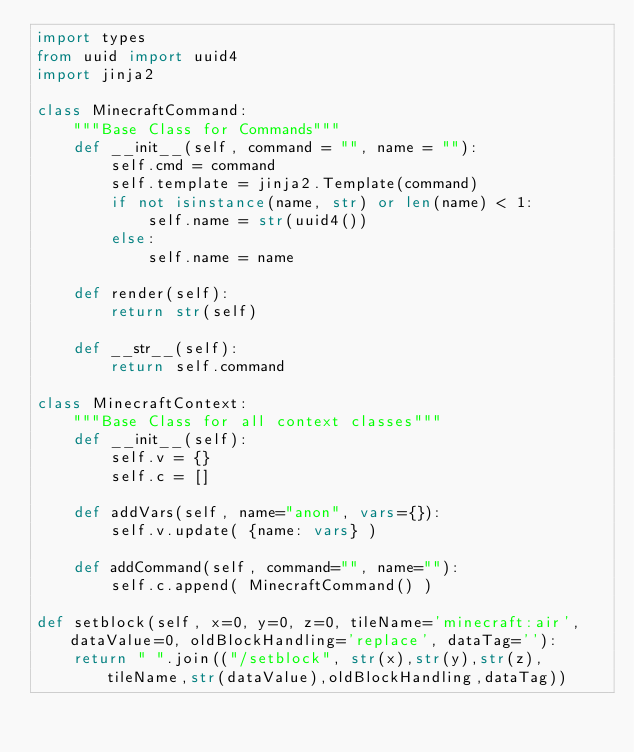<code> <loc_0><loc_0><loc_500><loc_500><_Python_>import types
from uuid import uuid4
import jinja2

class MinecraftCommand:
	"""Base Class for Commands"""
	def __init__(self, command = "", name = ""):
		self.cmd = command
		self.template = jinja2.Template(command)
		if not isinstance(name, str) or len(name) < 1:
			self.name = str(uuid4())
		else:
			self.name = name
	
	def render(self):
		return str(self)
	
	def __str__(self):
		return self.command

class MinecraftContext:
	"""Base Class for all context classes"""
	def __init__(self):
		self.v = {}
		self.c = []
	
	def addVars(self, name="anon", vars={}):
		self.v.update( {name: vars} )
	
	def addCommand(self, command="", name=""):
		self.c.append( MinecraftCommand() )
	
def setblock(self, x=0, y=0, z=0, tileName='minecraft:air', dataValue=0, oldBlockHandling='replace', dataTag=''):
	return " ".join(("/setblock", str(x),str(y),str(z),tileName,str(dataValue),oldBlockHandling,dataTag))
</code> 